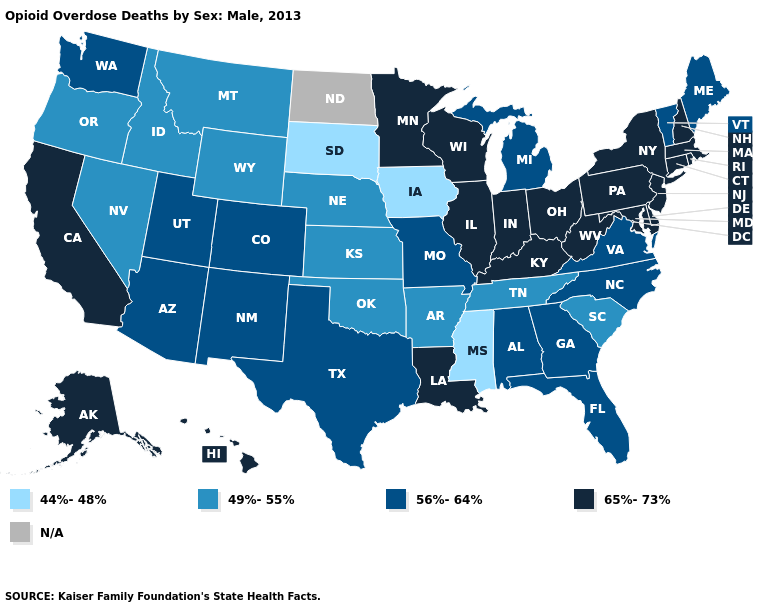What is the highest value in the USA?
Quick response, please. 65%-73%. Which states have the highest value in the USA?
Write a very short answer. Alaska, California, Connecticut, Delaware, Hawaii, Illinois, Indiana, Kentucky, Louisiana, Maryland, Massachusetts, Minnesota, New Hampshire, New Jersey, New York, Ohio, Pennsylvania, Rhode Island, West Virginia, Wisconsin. What is the value of Georgia?
Write a very short answer. 56%-64%. Name the states that have a value in the range 44%-48%?
Answer briefly. Iowa, Mississippi, South Dakota. Name the states that have a value in the range 65%-73%?
Quick response, please. Alaska, California, Connecticut, Delaware, Hawaii, Illinois, Indiana, Kentucky, Louisiana, Maryland, Massachusetts, Minnesota, New Hampshire, New Jersey, New York, Ohio, Pennsylvania, Rhode Island, West Virginia, Wisconsin. Among the states that border Florida , which have the lowest value?
Answer briefly. Alabama, Georgia. What is the lowest value in states that border South Carolina?
Be succinct. 56%-64%. What is the lowest value in the South?
Short answer required. 44%-48%. Among the states that border Vermont , which have the lowest value?
Short answer required. Massachusetts, New Hampshire, New York. Name the states that have a value in the range 44%-48%?
Short answer required. Iowa, Mississippi, South Dakota. Name the states that have a value in the range 56%-64%?
Write a very short answer. Alabama, Arizona, Colorado, Florida, Georgia, Maine, Michigan, Missouri, New Mexico, North Carolina, Texas, Utah, Vermont, Virginia, Washington. Which states hav the highest value in the MidWest?
Concise answer only. Illinois, Indiana, Minnesota, Ohio, Wisconsin. 